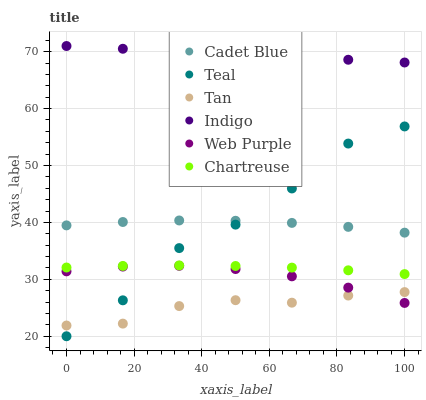Does Tan have the minimum area under the curve?
Answer yes or no. Yes. Does Indigo have the maximum area under the curve?
Answer yes or no. Yes. Does Web Purple have the minimum area under the curve?
Answer yes or no. No. Does Web Purple have the maximum area under the curve?
Answer yes or no. No. Is Indigo the smoothest?
Answer yes or no. Yes. Is Teal the roughest?
Answer yes or no. Yes. Is Web Purple the smoothest?
Answer yes or no. No. Is Web Purple the roughest?
Answer yes or no. No. Does Teal have the lowest value?
Answer yes or no. Yes. Does Web Purple have the lowest value?
Answer yes or no. No. Does Indigo have the highest value?
Answer yes or no. Yes. Does Web Purple have the highest value?
Answer yes or no. No. Is Web Purple less than Cadet Blue?
Answer yes or no. Yes. Is Indigo greater than Tan?
Answer yes or no. Yes. Does Web Purple intersect Tan?
Answer yes or no. Yes. Is Web Purple less than Tan?
Answer yes or no. No. Is Web Purple greater than Tan?
Answer yes or no. No. Does Web Purple intersect Cadet Blue?
Answer yes or no. No. 